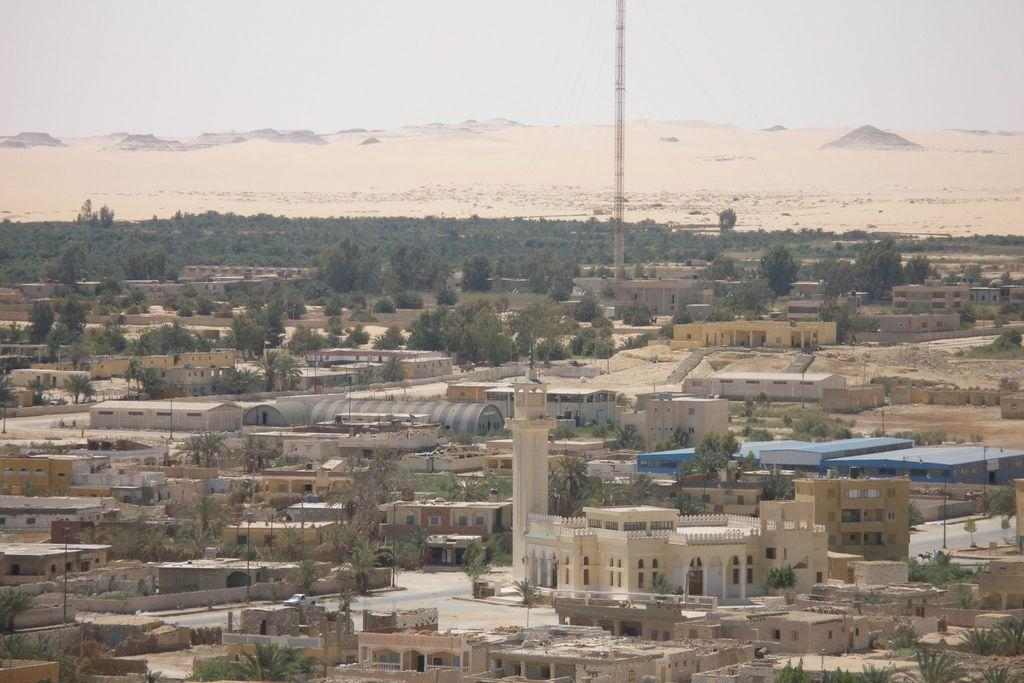What type of structures can be seen in the image? There are buildings in the image. What architectural features are visible on the buildings? There are windows visible on the buildings. What type of vegetation is present in the image? There are trees in the image. What tall structure can be seen in the image? There is a metal tower in the image. What is the color of the sky in the image? The sky is white in color. What type of zinc can be seen on the nose of the person in the image? There is no person present in the image, and therefore no nose or zinc can be observed. 